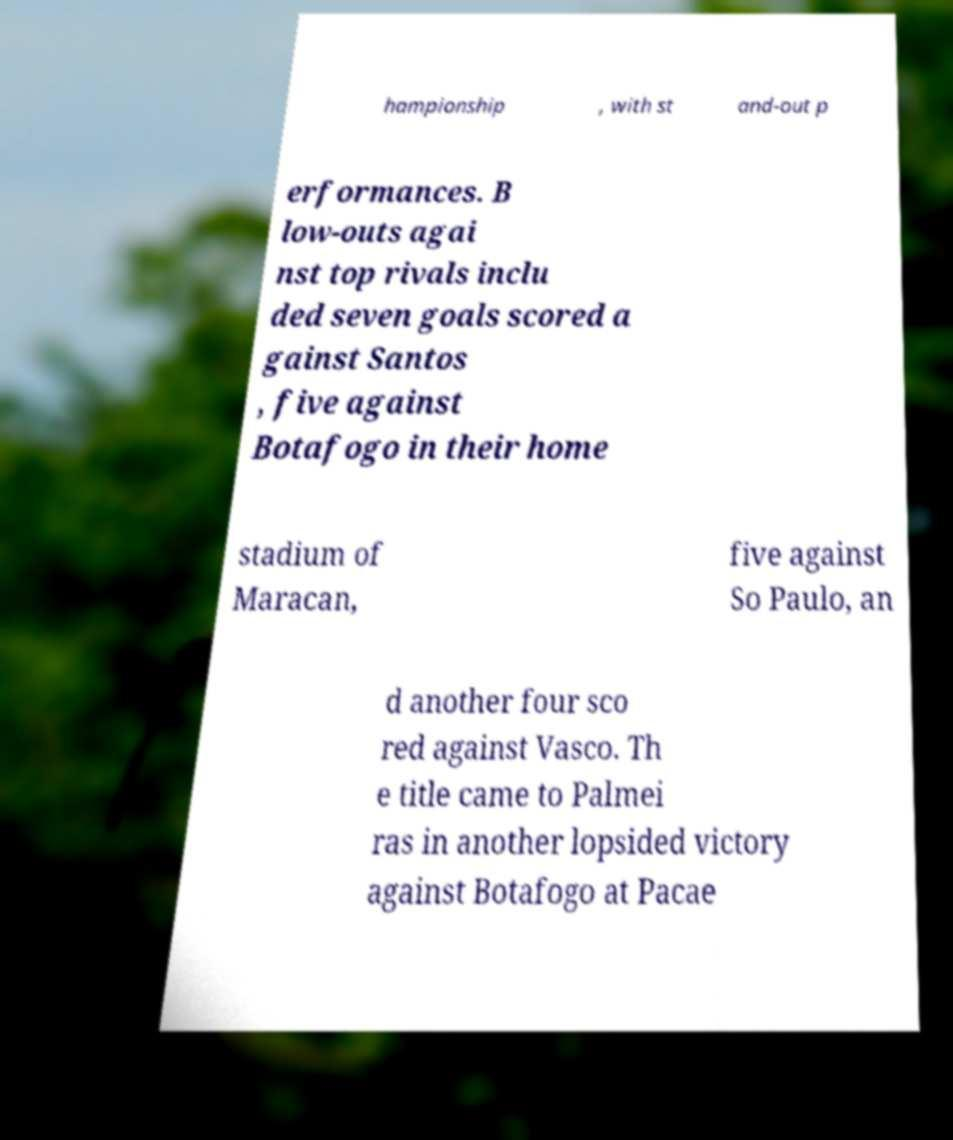Could you extract and type out the text from this image? hampionship , with st and-out p erformances. B low-outs agai nst top rivals inclu ded seven goals scored a gainst Santos , five against Botafogo in their home stadium of Maracan, five against So Paulo, an d another four sco red against Vasco. Th e title came to Palmei ras in another lopsided victory against Botafogo at Pacae 